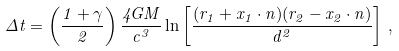<formula> <loc_0><loc_0><loc_500><loc_500>\Delta t = \left ( \frac { 1 + \gamma } { 2 } \right ) \frac { 4 G M } { c ^ { 3 } } \ln \left [ \frac { ( r _ { 1 } + { x } _ { 1 } \cdot { n } ) ( r _ { 2 } - { x } _ { 2 } \cdot { n } ) } { d ^ { 2 } } \right ] \, ,</formula> 